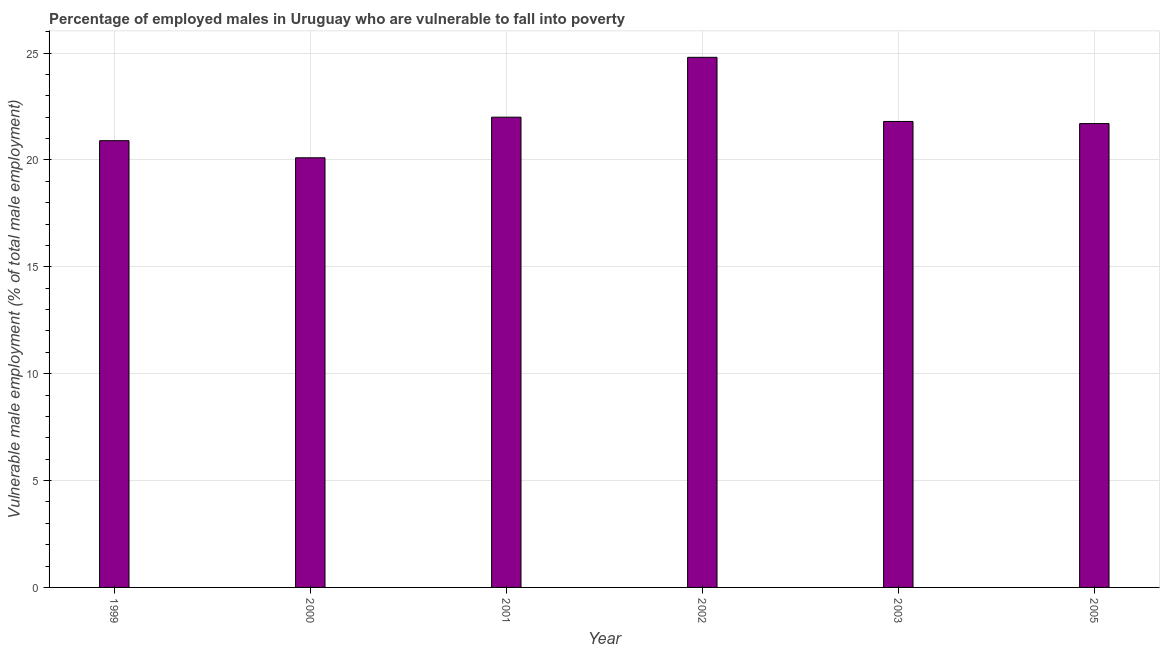Does the graph contain grids?
Ensure brevity in your answer.  Yes. What is the title of the graph?
Provide a short and direct response. Percentage of employed males in Uruguay who are vulnerable to fall into poverty. What is the label or title of the X-axis?
Offer a terse response. Year. What is the label or title of the Y-axis?
Keep it short and to the point. Vulnerable male employment (% of total male employment). What is the percentage of employed males who are vulnerable to fall into poverty in 1999?
Make the answer very short. 20.9. Across all years, what is the maximum percentage of employed males who are vulnerable to fall into poverty?
Give a very brief answer. 24.8. Across all years, what is the minimum percentage of employed males who are vulnerable to fall into poverty?
Make the answer very short. 20.1. In which year was the percentage of employed males who are vulnerable to fall into poverty maximum?
Provide a succinct answer. 2002. What is the sum of the percentage of employed males who are vulnerable to fall into poverty?
Your answer should be very brief. 131.3. What is the difference between the percentage of employed males who are vulnerable to fall into poverty in 2002 and 2005?
Offer a terse response. 3.1. What is the average percentage of employed males who are vulnerable to fall into poverty per year?
Offer a very short reply. 21.88. What is the median percentage of employed males who are vulnerable to fall into poverty?
Make the answer very short. 21.75. In how many years, is the percentage of employed males who are vulnerable to fall into poverty greater than 8 %?
Give a very brief answer. 6. What is the ratio of the percentage of employed males who are vulnerable to fall into poverty in 2002 to that in 2003?
Make the answer very short. 1.14. Is the difference between the percentage of employed males who are vulnerable to fall into poverty in 2001 and 2002 greater than the difference between any two years?
Offer a very short reply. No. What is the difference between the highest and the second highest percentage of employed males who are vulnerable to fall into poverty?
Keep it short and to the point. 2.8. What is the difference between the highest and the lowest percentage of employed males who are vulnerable to fall into poverty?
Your answer should be compact. 4.7. Are all the bars in the graph horizontal?
Offer a very short reply. No. What is the difference between two consecutive major ticks on the Y-axis?
Your answer should be compact. 5. Are the values on the major ticks of Y-axis written in scientific E-notation?
Provide a short and direct response. No. What is the Vulnerable male employment (% of total male employment) in 1999?
Give a very brief answer. 20.9. What is the Vulnerable male employment (% of total male employment) in 2000?
Provide a succinct answer. 20.1. What is the Vulnerable male employment (% of total male employment) in 2001?
Your response must be concise. 22. What is the Vulnerable male employment (% of total male employment) in 2002?
Give a very brief answer. 24.8. What is the Vulnerable male employment (% of total male employment) in 2003?
Offer a very short reply. 21.8. What is the Vulnerable male employment (% of total male employment) in 2005?
Keep it short and to the point. 21.7. What is the difference between the Vulnerable male employment (% of total male employment) in 1999 and 2002?
Offer a very short reply. -3.9. What is the difference between the Vulnerable male employment (% of total male employment) in 1999 and 2003?
Provide a short and direct response. -0.9. What is the difference between the Vulnerable male employment (% of total male employment) in 1999 and 2005?
Offer a very short reply. -0.8. What is the difference between the Vulnerable male employment (% of total male employment) in 2000 and 2002?
Your answer should be compact. -4.7. What is the difference between the Vulnerable male employment (% of total male employment) in 2000 and 2003?
Provide a succinct answer. -1.7. What is the difference between the Vulnerable male employment (% of total male employment) in 2000 and 2005?
Your response must be concise. -1.6. What is the difference between the Vulnerable male employment (% of total male employment) in 2001 and 2003?
Your response must be concise. 0.2. What is the difference between the Vulnerable male employment (% of total male employment) in 2002 and 2003?
Provide a succinct answer. 3. What is the difference between the Vulnerable male employment (% of total male employment) in 2003 and 2005?
Offer a terse response. 0.1. What is the ratio of the Vulnerable male employment (% of total male employment) in 1999 to that in 2000?
Your answer should be compact. 1.04. What is the ratio of the Vulnerable male employment (% of total male employment) in 1999 to that in 2002?
Provide a short and direct response. 0.84. What is the ratio of the Vulnerable male employment (% of total male employment) in 1999 to that in 2005?
Your response must be concise. 0.96. What is the ratio of the Vulnerable male employment (% of total male employment) in 2000 to that in 2001?
Your answer should be compact. 0.91. What is the ratio of the Vulnerable male employment (% of total male employment) in 2000 to that in 2002?
Your answer should be compact. 0.81. What is the ratio of the Vulnerable male employment (% of total male employment) in 2000 to that in 2003?
Make the answer very short. 0.92. What is the ratio of the Vulnerable male employment (% of total male employment) in 2000 to that in 2005?
Your answer should be compact. 0.93. What is the ratio of the Vulnerable male employment (% of total male employment) in 2001 to that in 2002?
Provide a succinct answer. 0.89. What is the ratio of the Vulnerable male employment (% of total male employment) in 2001 to that in 2003?
Offer a terse response. 1.01. What is the ratio of the Vulnerable male employment (% of total male employment) in 2001 to that in 2005?
Provide a short and direct response. 1.01. What is the ratio of the Vulnerable male employment (% of total male employment) in 2002 to that in 2003?
Provide a succinct answer. 1.14. What is the ratio of the Vulnerable male employment (% of total male employment) in 2002 to that in 2005?
Provide a succinct answer. 1.14. What is the ratio of the Vulnerable male employment (% of total male employment) in 2003 to that in 2005?
Your answer should be compact. 1. 